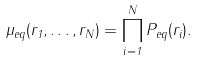<formula> <loc_0><loc_0><loc_500><loc_500>\mu _ { e q } ( { r } _ { 1 } , \dots , { r } _ { N } ) = \prod _ { i = 1 } ^ { N } P _ { e q } ( { r } _ { i } ) .</formula> 